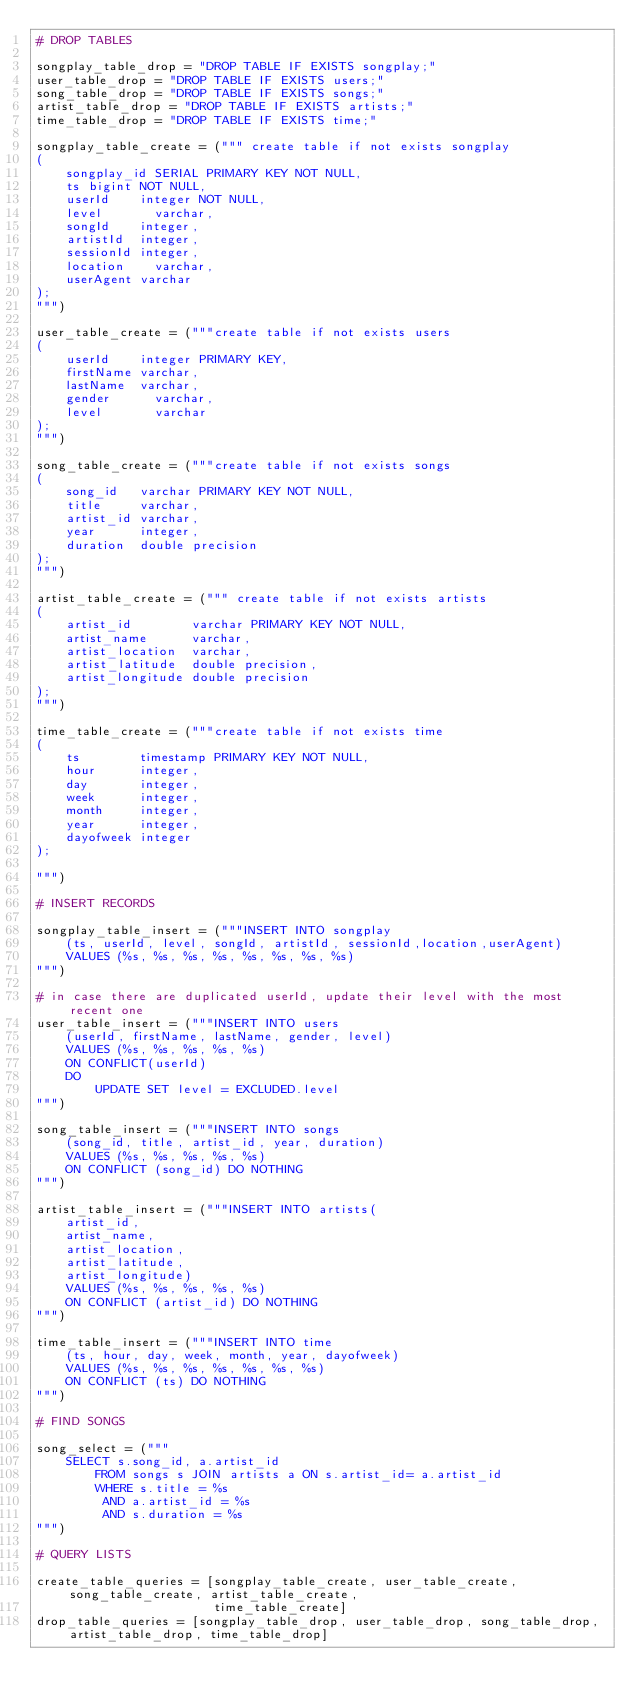<code> <loc_0><loc_0><loc_500><loc_500><_Python_># DROP TABLES

songplay_table_drop = "DROP TABLE IF EXISTS songplay;"
user_table_drop = "DROP TABLE IF EXISTS users;"
song_table_drop = "DROP TABLE IF EXISTS songs;"
artist_table_drop = "DROP TABLE IF EXISTS artists;"
time_table_drop = "DROP TABLE IF EXISTS time;"

songplay_table_create = (""" create table if not exists songplay
(
    songplay_id SERIAL PRIMARY KEY NOT NULL,
    ts bigint NOT NULL,
    userId    integer NOT NULL,
    level       varchar,
    songId    integer,
    artistId  integer,
    sessionId integer,
    location    varchar,
    userAgent varchar
);
""")

user_table_create = ("""create table if not exists users
(
    userId    integer PRIMARY KEY,
    firstName varchar,
    lastName  varchar,
    gender      varchar,
    level       varchar
);
""")

song_table_create = ("""create table if not exists songs
(
    song_id   varchar PRIMARY KEY NOT NULL,
    title     varchar,
    artist_id varchar,
    year      integer,
    duration  double precision
);
""")

artist_table_create = (""" create table if not exists artists
(
    artist_id        varchar PRIMARY KEY NOT NULL,
    artist_name      varchar,
    artist_location  varchar,
    artist_latitude  double precision,
    artist_longitude double precision
);
""")

time_table_create = ("""create table if not exists time
(
    ts        timestamp PRIMARY KEY NOT NULL,
    hour      integer,
    day       integer,
    week      integer,
    month     integer,
    year      integer,
    dayofweek integer
);

""")

# INSERT RECORDS

songplay_table_insert = ("""INSERT INTO songplay
    (ts, userId, level, songId, artistId, sessionId,location,userAgent)
    VALUES (%s, %s, %s, %s, %s, %s, %s, %s)
""")

# in case there are duplicated userId, update their level with the most recent one
user_table_insert = ("""INSERT INTO users
    (userId, firstName, lastName, gender, level)
    VALUES (%s, %s, %s, %s, %s)
    ON CONFLICT(userId)
    DO 
        UPDATE SET level = EXCLUDED.level
""")

song_table_insert = ("""INSERT INTO songs
    (song_id, title, artist_id, year, duration)
    VALUES (%s, %s, %s, %s, %s)
    ON CONFLICT (song_id) DO NOTHING
""")

artist_table_insert = ("""INSERT INTO artists(
    artist_id,
    artist_name,
    artist_location,
    artist_latitude,
    artist_longitude)
    VALUES (%s, %s, %s, %s, %s)
    ON CONFLICT (artist_id) DO NOTHING
""")

time_table_insert = ("""INSERT INTO time
    (ts, hour, day, week, month, year, dayofweek)
    VALUES (%s, %s, %s, %s, %s, %s, %s)
    ON CONFLICT (ts) DO NOTHING
""")

# FIND SONGS

song_select = ("""
    SELECT s.song_id, a.artist_id 
        FROM songs s JOIN artists a ON s.artist_id= a.artist_id
        WHERE s.title = %s 
         AND a.artist_id = %s 
         AND s.duration = %s
""")

# QUERY LISTS

create_table_queries = [songplay_table_create, user_table_create, song_table_create, artist_table_create,
                        time_table_create]
drop_table_queries = [songplay_table_drop, user_table_drop, song_table_drop, artist_table_drop, time_table_drop]
</code> 